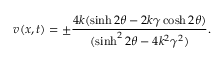<formula> <loc_0><loc_0><loc_500><loc_500>v ( x , t ) = \pm \frac { 4 k ( \sinh 2 \theta - 2 k \gamma \cosh 2 \theta ) } { ( \sinh ^ { 2 } 2 \theta - 4 k ^ { 2 } \gamma ^ { 2 } ) } .</formula> 